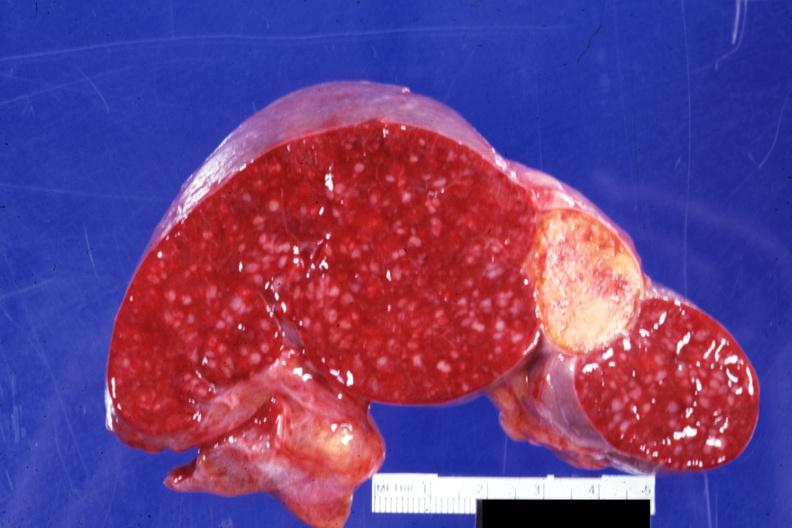s hematologic present?
Answer the question using a single word or phrase. Yes 